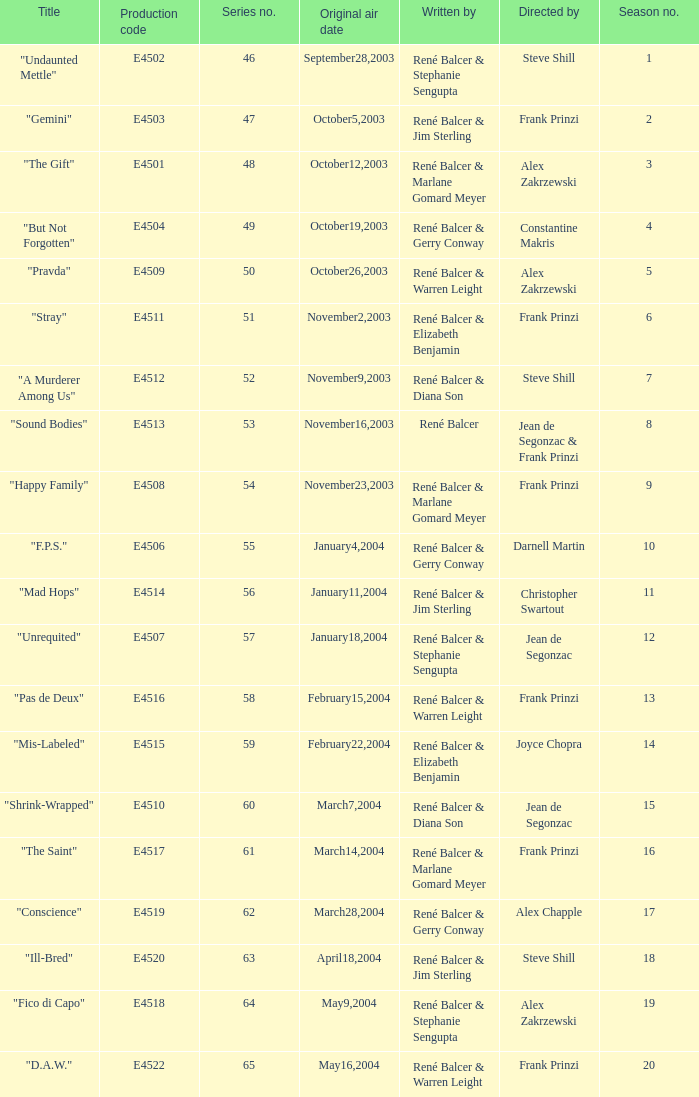What episode number in the season is titled "stray"? 6.0. 